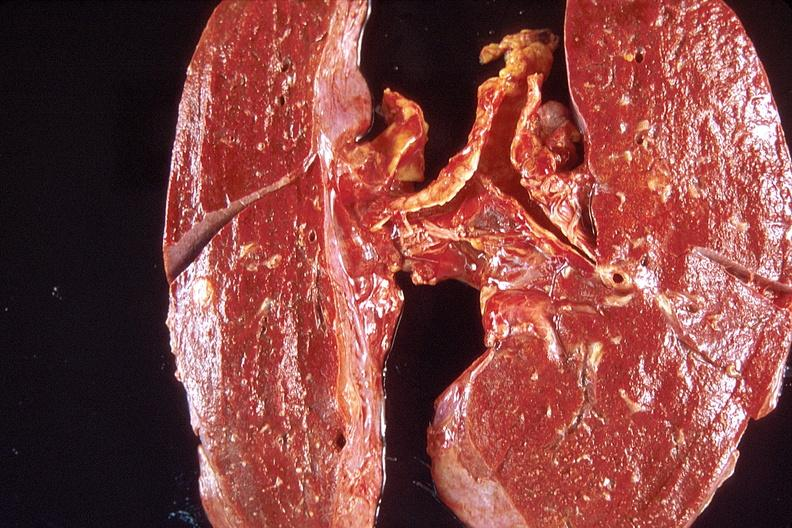does cat show lung, diffuse alveolar damage?
Answer the question using a single word or phrase. No 